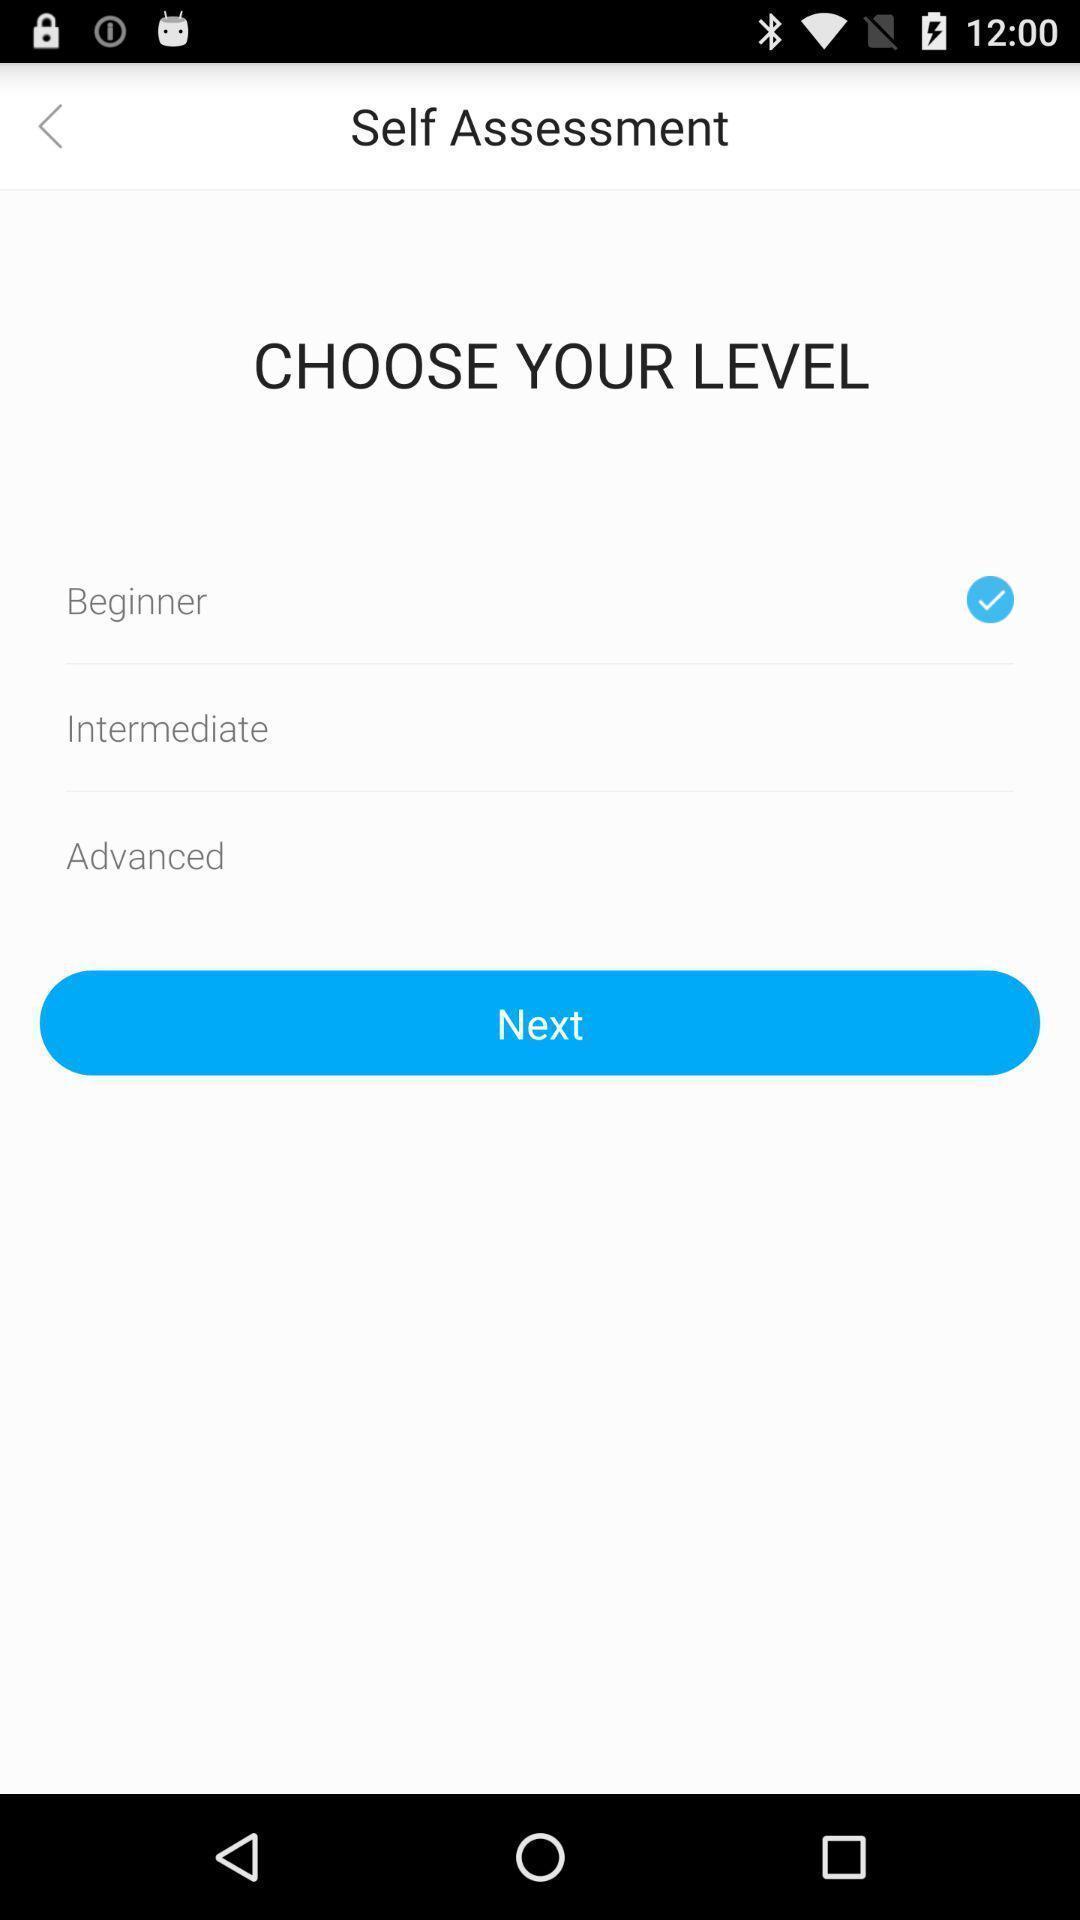Give me a summary of this screen capture. Self assessment page with different level options on study app. 